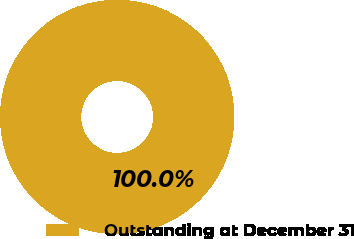<chart> <loc_0><loc_0><loc_500><loc_500><pie_chart><fcel>Outstanding at December 31<nl><fcel>100.0%<nl></chart> 